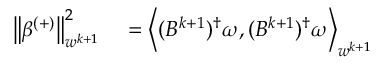Convert formula to latex. <formula><loc_0><loc_0><loc_500><loc_500>\begin{array} { r l } { \left \| \beta ^ { ( + ) } \right \| _ { w ^ { k + 1 } } ^ { 2 } } & = \left \langle ( B ^ { k + 1 } ) ^ { \dagger } \omega , ( B ^ { k + 1 } ) ^ { \dagger } \omega \right \rangle _ { w ^ { k + 1 } } } \end{array}</formula> 